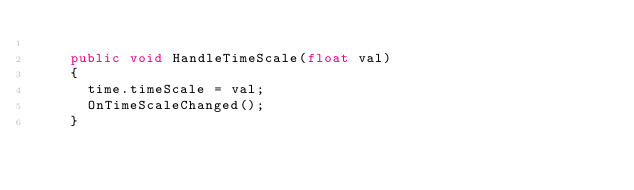Convert code to text. <code><loc_0><loc_0><loc_500><loc_500><_C#_>
		public void HandleTimeScale(float val)
		{
			time.timeScale = val;
			OnTimeScaleChanged();
		}

</code> 